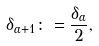<formula> <loc_0><loc_0><loc_500><loc_500>\delta _ { \alpha + 1 } \colon = \frac { \delta _ { \alpha } } { 2 } ,</formula> 